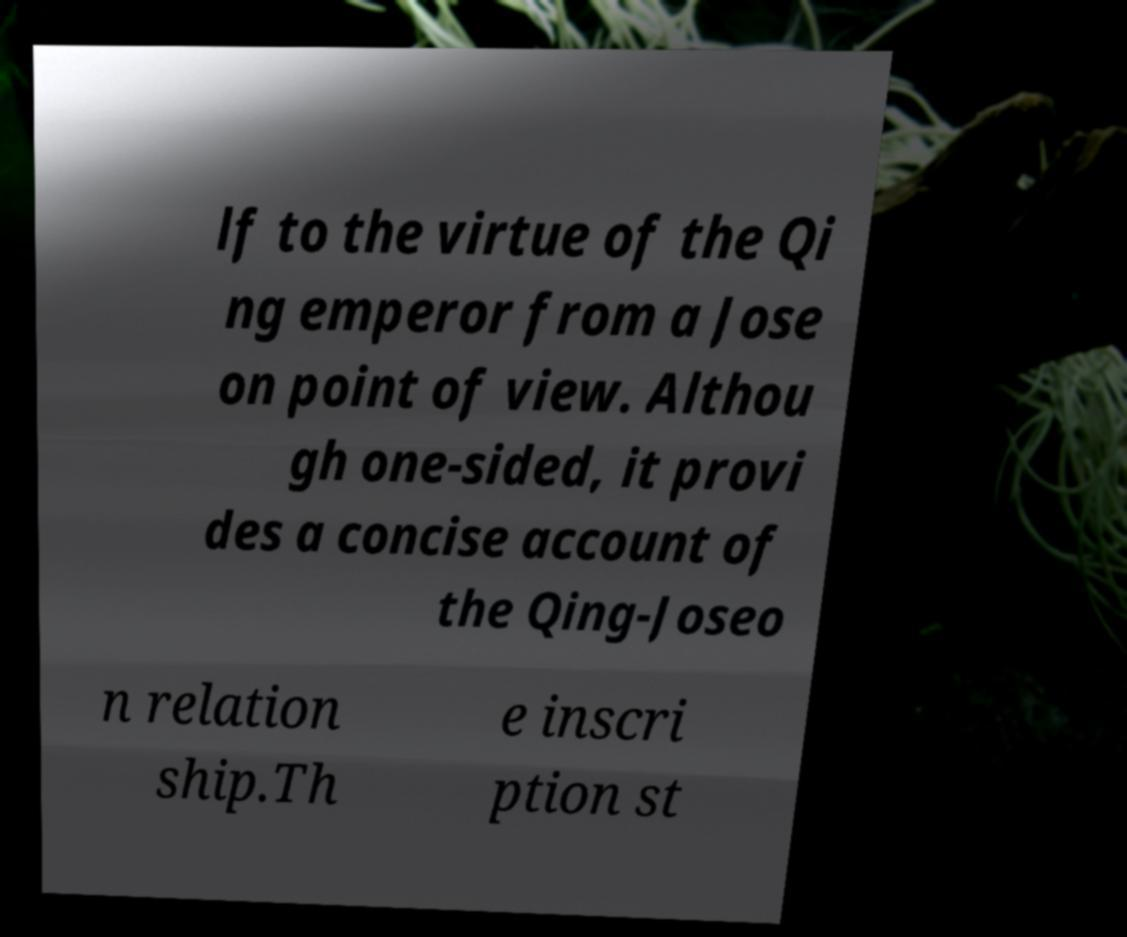Could you assist in decoding the text presented in this image and type it out clearly? lf to the virtue of the Qi ng emperor from a Jose on point of view. Althou gh one-sided, it provi des a concise account of the Qing-Joseo n relation ship.Th e inscri ption st 